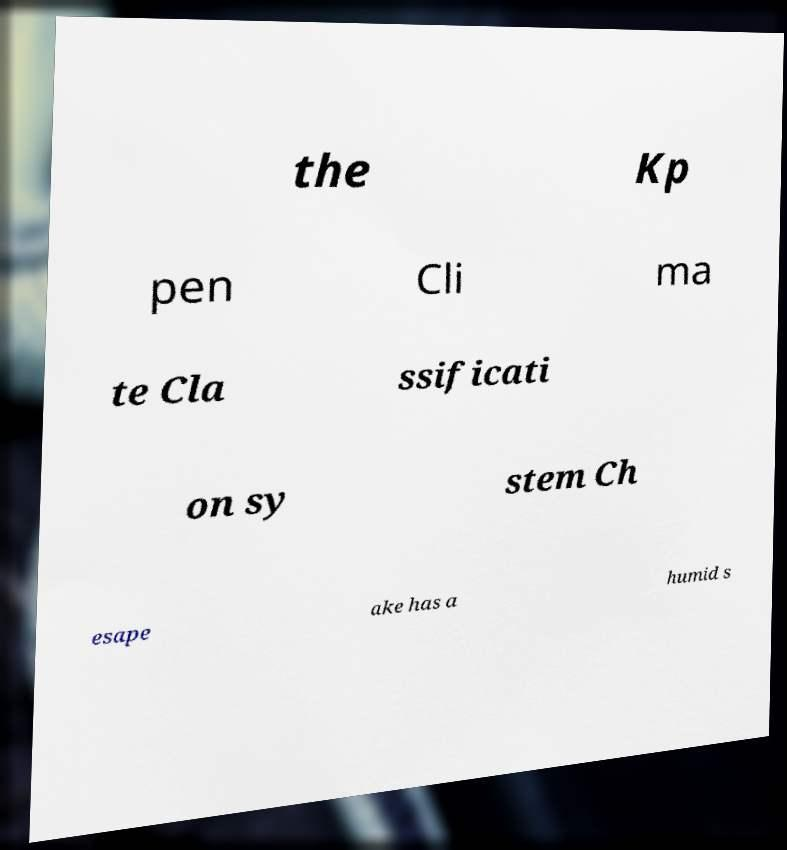Please identify and transcribe the text found in this image. the Kp pen Cli ma te Cla ssificati on sy stem Ch esape ake has a humid s 